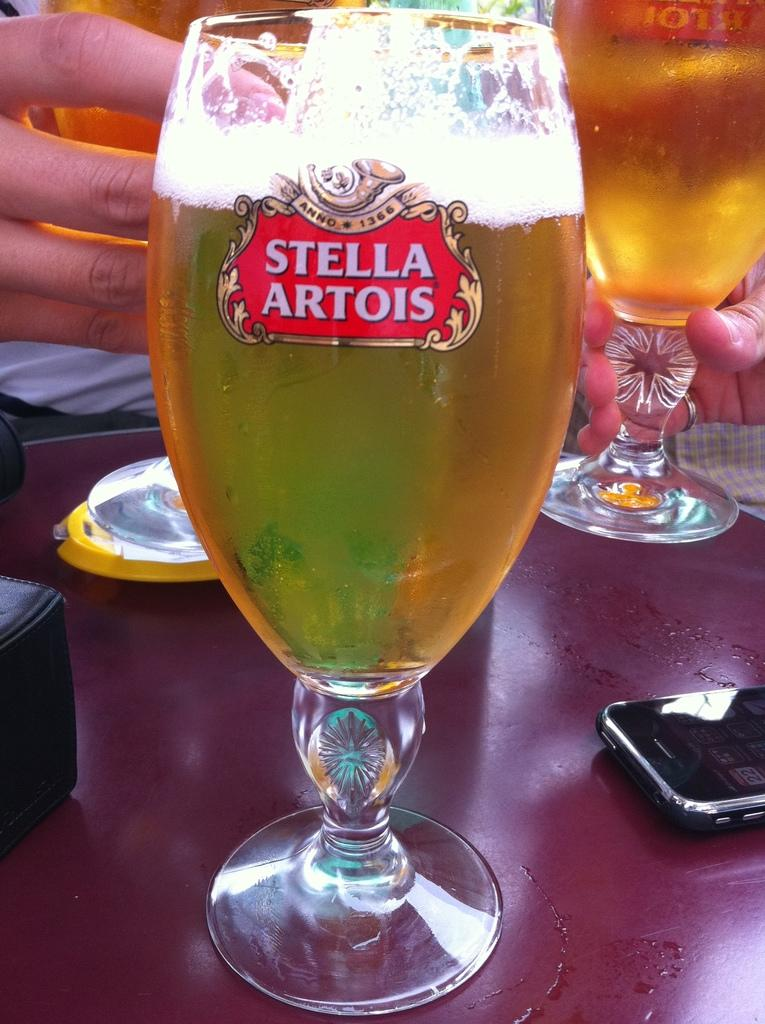<image>
Give a short and clear explanation of the subsequent image. a glass with stella artois on the front 